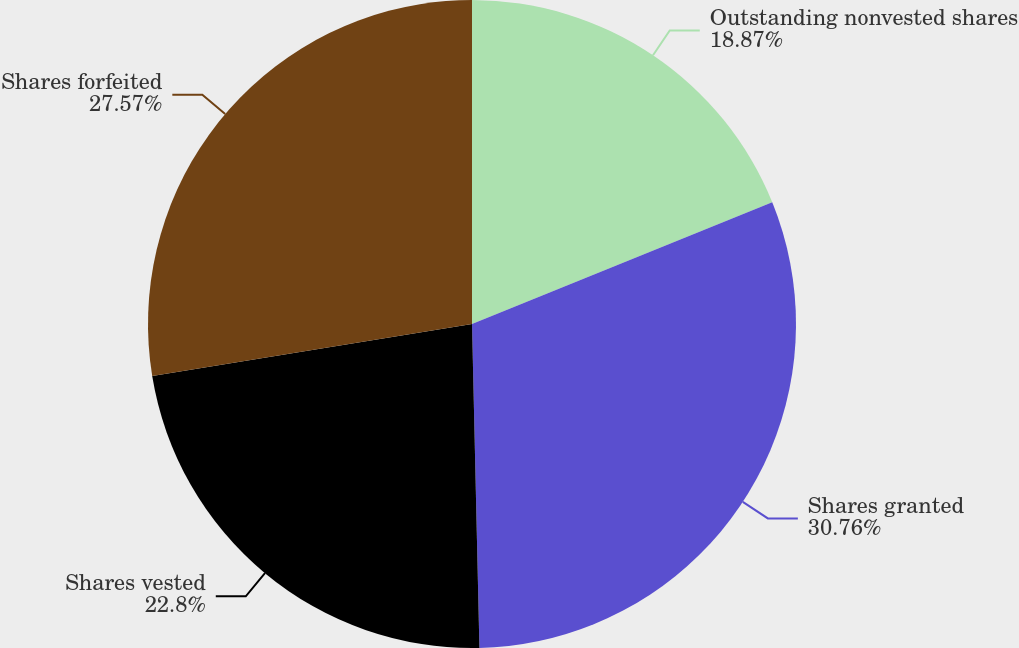<chart> <loc_0><loc_0><loc_500><loc_500><pie_chart><fcel>Outstanding nonvested shares<fcel>Shares granted<fcel>Shares vested<fcel>Shares forfeited<nl><fcel>18.87%<fcel>30.77%<fcel>22.8%<fcel>27.57%<nl></chart> 